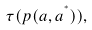Convert formula to latex. <formula><loc_0><loc_0><loc_500><loc_500>\tau ( p ( a , a ^ { ^ { * } } ) ) ,</formula> 